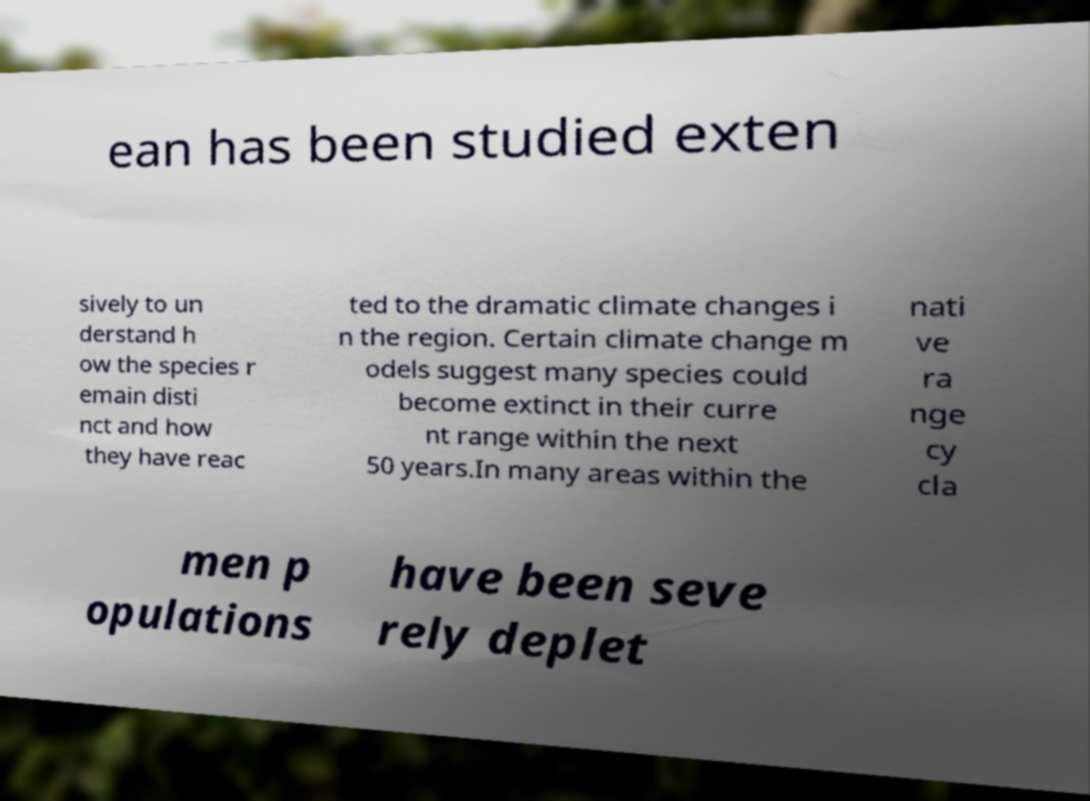There's text embedded in this image that I need extracted. Can you transcribe it verbatim? ean has been studied exten sively to un derstand h ow the species r emain disti nct and how they have reac ted to the dramatic climate changes i n the region. Certain climate change m odels suggest many species could become extinct in their curre nt range within the next 50 years.In many areas within the nati ve ra nge cy cla men p opulations have been seve rely deplet 